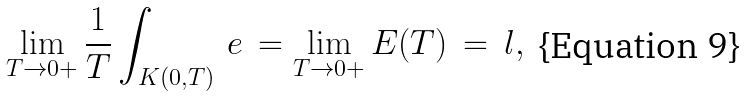<formula> <loc_0><loc_0><loc_500><loc_500>\lim _ { T \to 0 + } \frac { 1 } { T } \int _ { K ( 0 , T ) } \, e \, = \lim _ { T \to 0 + } E ( T ) \, = \, l ,</formula> 